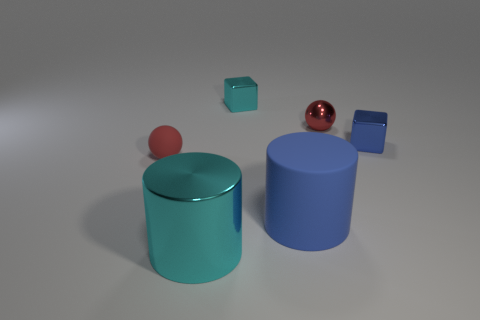Could you envision a practical use for the arrangement of these objects? While the arrangement appears to be aesthetic in nature, one could conceptualize a simplistic children's toy, with elements that can be stacked or sorted by size and shape. Another possible utility could be a modern art display, where the combination of forms and colors is used to create visual interest and provoke thought in the observer. 